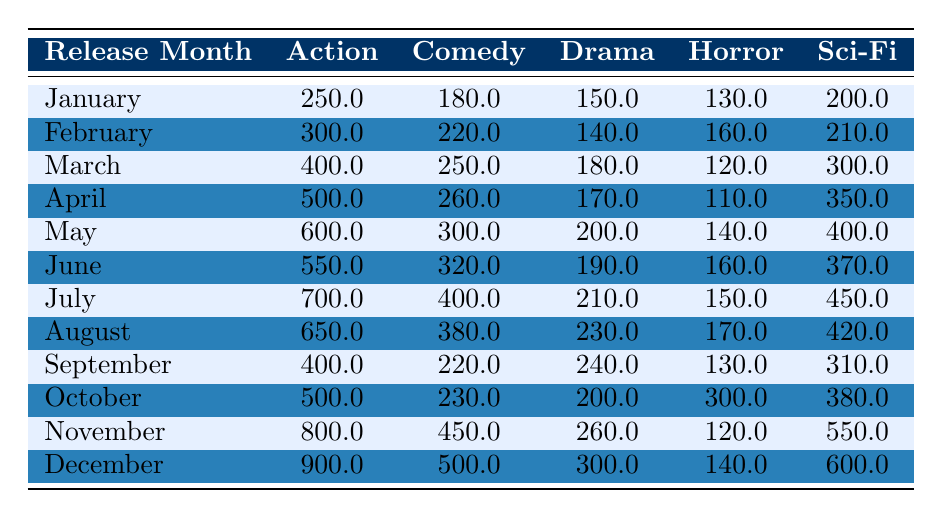What was the highest box office earnings for action films in any month? The table shows box office earnings for action films in December (900 million), which is the highest value across all months.
Answer: 900000000 Which month had the least box office earnings for horror films? The table indicates the month with the least box office earnings for horror is April, where it earned 110 million.
Answer: 110000000 What is the total box office earnings for comedy films released from January to March? By summing the comedy earnings for these months, we get: January (180 million) + February (220 million) + March (250 million) = 650 million.
Answer: 650000000 In which month did sci-fi films earn the most box office earnings? According to the table, sci-fi films earned the most in December with 600 million.
Answer: December What is the average box office earnings for drama films over the entire year? To find the average, sum the drama earnings (150+140+180+170+200+190+210+230+240+200+260+300 = 2370 million), then divide by 12 months (2370/12 = 197.5 million).
Answer: 197500000 Which genre had the highest total earnings in November? The table shows that in November, action (800 million) surpassed comedy (450 million), drama (260 million), horror (120 million), and sci-fi (550 million), confirming action had the highest.
Answer: Action How much more did sci-fi films earn in December compared to August? December earned 600 million for sci-fi while August earned 420 million, thus the difference is 600 - 420 = 180 million.
Answer: 180000000 What is the cumulative earnings for horror films over the entire year? Summing up the horror earnings from each month gives a total of: 130 + 160 + 120 + 110 + 140 + 160 + 150 + 170 + 130 + 300 + 120 + 140 = 1960 million.
Answer: 196000000 Did comedy films earn more than horror films in July? In July, comedy films earned 400 million while horror films earned 150 million, indicating comedy films did earn more.
Answer: Yes Which genre had the majority of its monthly earnings consistently higher throughout the year? By examining the monthly totals, action consistently shows higher earnings month-over-month than any other genre, especially notable starting from April onwards.
Answer: Action 